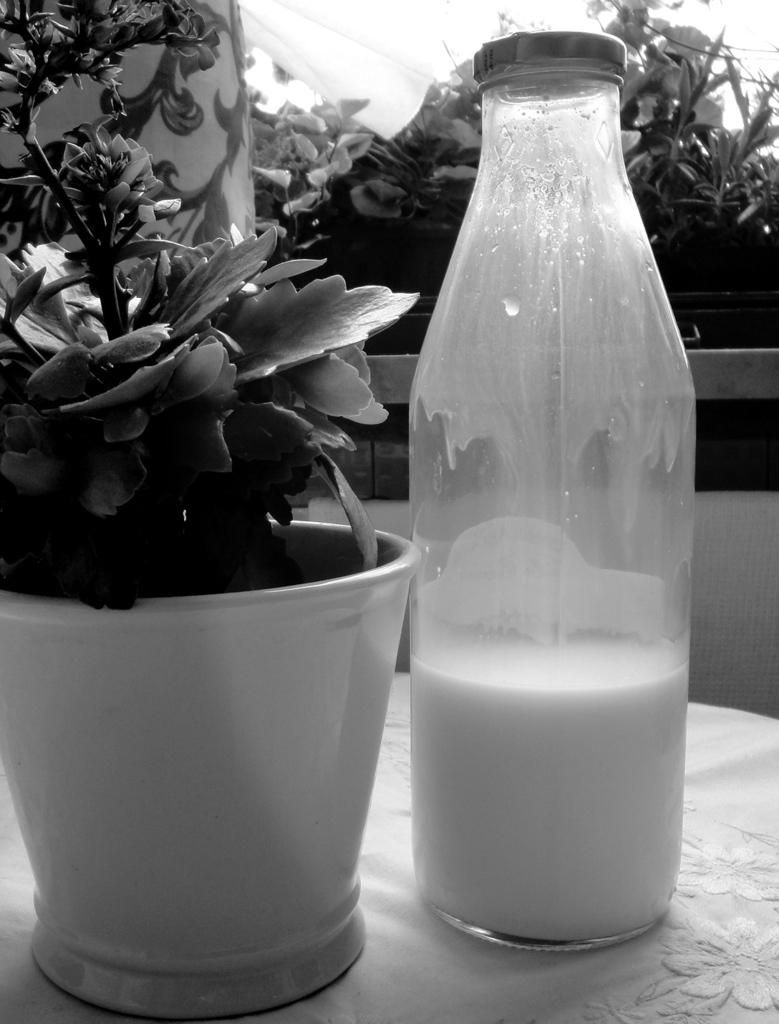What is placed on the table in the image? There is a bottle of milk on a table. What else is on the table in the image? There is a flower pot on the table. What type of vegetation is visible in the image? There are plants visible in the image. Can you see a fireman putting out a fire in the image? There is no fireman or fire present in the image. What shape is the flower pot in the image? The provided facts do not mention the shape of the flower pot, so it cannot be determined from the image. 